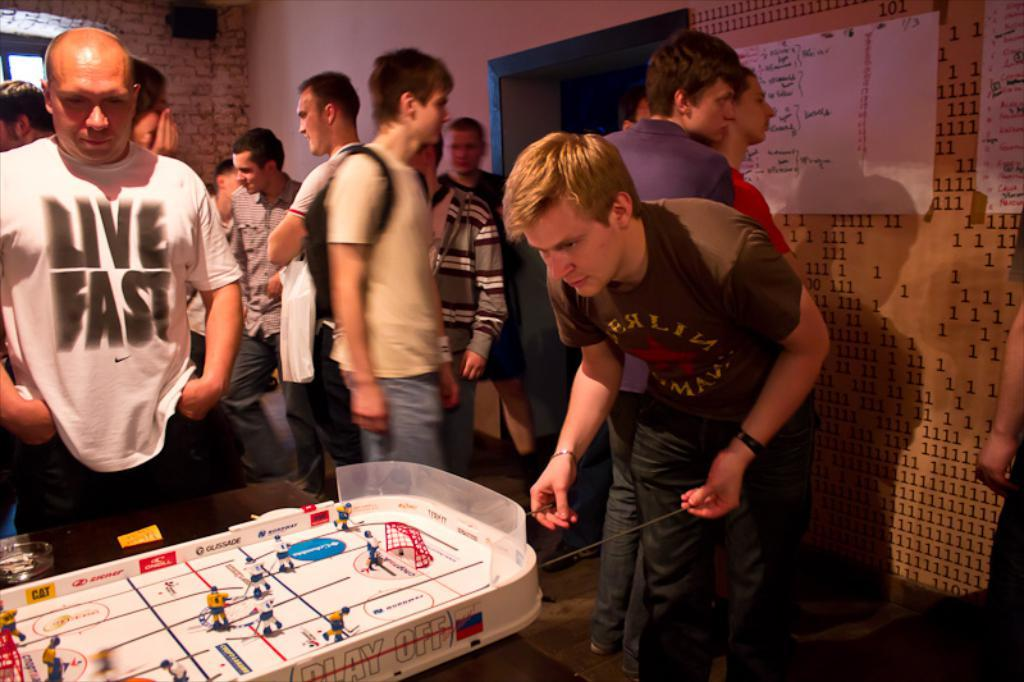How many people are in the image? There is a group of people in the image. What is the position of the people in the image? The people are standing on the floor. What else can be seen in the image besides the people? There are toys visible in the image. What is on the table in the image? There is a glass on a table in the image. What can be seen in the background of the image? There is a wall in the background of the image, and there are posters on the wall. How many thumbs are visible in the image? There is no specific information about the number of thumbs visible in the image, as it focuses on the group of people and their surroundings. 